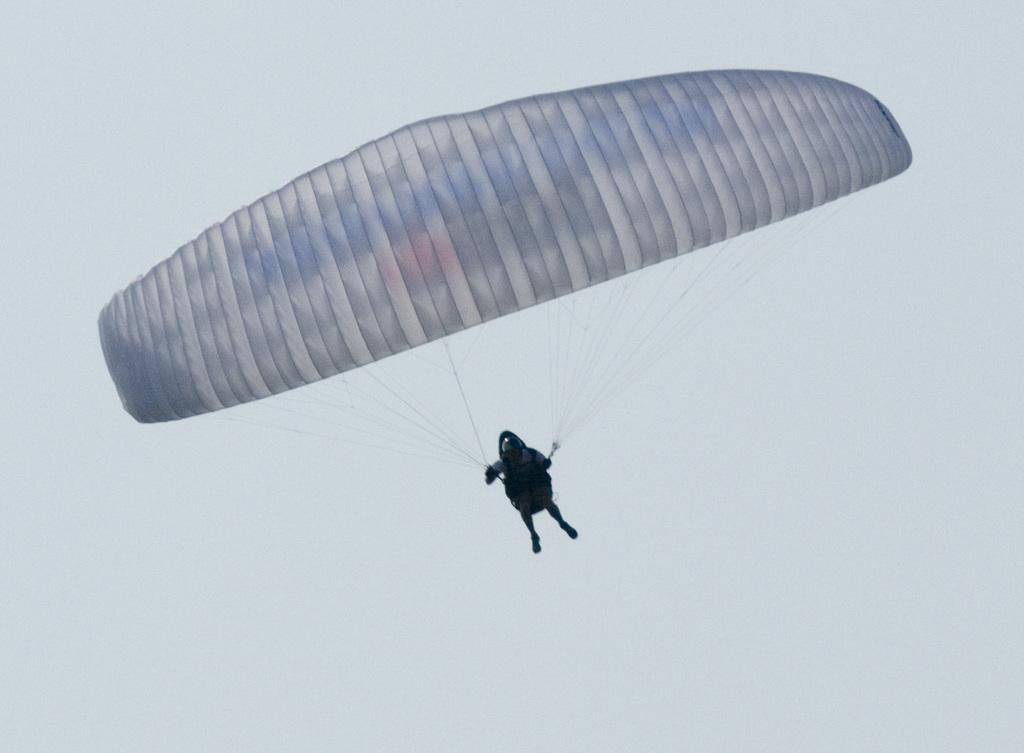What is the main activity being performed in the image? There is a person paragliding in the image. What is visible in the background of the image? The sky is visible in the image. Can you describe the sky's condition in the image? The sky appears to be cloudy in the image. How does the person paragliding in the image react to the earthquake? There is no earthquake present in the image; it only features a person paragliding in a cloudy sky. 